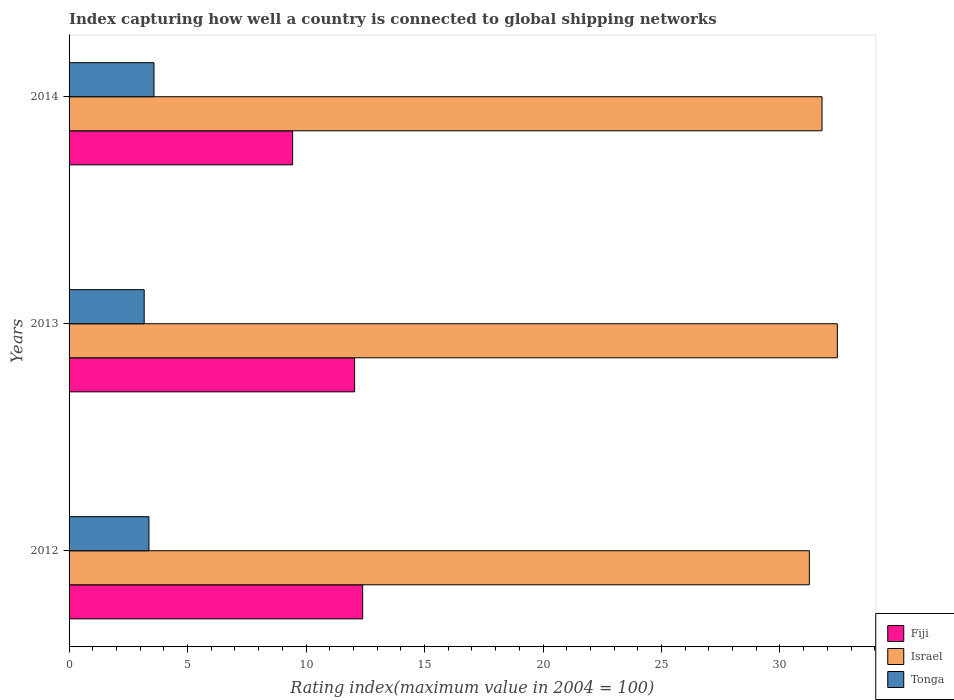How many different coloured bars are there?
Keep it short and to the point. 3. How many groups of bars are there?
Give a very brief answer. 3. Are the number of bars per tick equal to the number of legend labels?
Your answer should be very brief. Yes. Are the number of bars on each tick of the Y-axis equal?
Ensure brevity in your answer.  Yes. What is the rating index in Israel in 2014?
Offer a very short reply. 31.77. Across all years, what is the maximum rating index in Fiji?
Your response must be concise. 12.39. Across all years, what is the minimum rating index in Fiji?
Your response must be concise. 9.43. In which year was the rating index in Tonga maximum?
Your answer should be compact. 2014. What is the total rating index in Israel in the graph?
Your answer should be very brief. 95.43. What is the difference between the rating index in Israel in 2013 and that in 2014?
Keep it short and to the point. 0.65. What is the difference between the rating index in Israel in 2013 and the rating index in Tonga in 2012?
Make the answer very short. 29.05. What is the average rating index in Fiji per year?
Provide a short and direct response. 11.29. In the year 2014, what is the difference between the rating index in Israel and rating index in Tonga?
Offer a very short reply. 28.19. What is the ratio of the rating index in Israel in 2013 to that in 2014?
Provide a short and direct response. 1.02. Is the rating index in Israel in 2012 less than that in 2014?
Your response must be concise. Yes. Is the difference between the rating index in Israel in 2013 and 2014 greater than the difference between the rating index in Tonga in 2013 and 2014?
Your response must be concise. Yes. What is the difference between the highest and the second highest rating index in Tonga?
Keep it short and to the point. 0.21. What is the difference between the highest and the lowest rating index in Israel?
Your response must be concise. 1.18. In how many years, is the rating index in Tonga greater than the average rating index in Tonga taken over all years?
Give a very brief answer. 1. Is the sum of the rating index in Tonga in 2013 and 2014 greater than the maximum rating index in Israel across all years?
Provide a succinct answer. No. What does the 1st bar from the top in 2013 represents?
Keep it short and to the point. Tonga. What does the 1st bar from the bottom in 2014 represents?
Provide a succinct answer. Fiji. How many bars are there?
Provide a succinct answer. 9. Does the graph contain grids?
Give a very brief answer. No. How many legend labels are there?
Your answer should be compact. 3. How are the legend labels stacked?
Keep it short and to the point. Vertical. What is the title of the graph?
Your answer should be compact. Index capturing how well a country is connected to global shipping networks. What is the label or title of the X-axis?
Offer a very short reply. Rating index(maximum value in 2004 = 100). What is the Rating index(maximum value in 2004 = 100) of Fiji in 2012?
Your response must be concise. 12.39. What is the Rating index(maximum value in 2004 = 100) of Israel in 2012?
Provide a short and direct response. 31.24. What is the Rating index(maximum value in 2004 = 100) of Tonga in 2012?
Make the answer very short. 3.37. What is the Rating index(maximum value in 2004 = 100) in Fiji in 2013?
Keep it short and to the point. 12.05. What is the Rating index(maximum value in 2004 = 100) of Israel in 2013?
Your response must be concise. 32.42. What is the Rating index(maximum value in 2004 = 100) of Tonga in 2013?
Ensure brevity in your answer.  3.17. What is the Rating index(maximum value in 2004 = 100) of Fiji in 2014?
Offer a very short reply. 9.43. What is the Rating index(maximum value in 2004 = 100) of Israel in 2014?
Give a very brief answer. 31.77. What is the Rating index(maximum value in 2004 = 100) of Tonga in 2014?
Your response must be concise. 3.58. Across all years, what is the maximum Rating index(maximum value in 2004 = 100) of Fiji?
Provide a short and direct response. 12.39. Across all years, what is the maximum Rating index(maximum value in 2004 = 100) in Israel?
Ensure brevity in your answer.  32.42. Across all years, what is the maximum Rating index(maximum value in 2004 = 100) of Tonga?
Provide a short and direct response. 3.58. Across all years, what is the minimum Rating index(maximum value in 2004 = 100) in Fiji?
Your answer should be compact. 9.43. Across all years, what is the minimum Rating index(maximum value in 2004 = 100) of Israel?
Your answer should be compact. 31.24. Across all years, what is the minimum Rating index(maximum value in 2004 = 100) in Tonga?
Offer a very short reply. 3.17. What is the total Rating index(maximum value in 2004 = 100) in Fiji in the graph?
Ensure brevity in your answer.  33.87. What is the total Rating index(maximum value in 2004 = 100) of Israel in the graph?
Keep it short and to the point. 95.43. What is the total Rating index(maximum value in 2004 = 100) in Tonga in the graph?
Make the answer very short. 10.12. What is the difference between the Rating index(maximum value in 2004 = 100) of Fiji in 2012 and that in 2013?
Your response must be concise. 0.34. What is the difference between the Rating index(maximum value in 2004 = 100) of Israel in 2012 and that in 2013?
Provide a succinct answer. -1.18. What is the difference between the Rating index(maximum value in 2004 = 100) in Fiji in 2012 and that in 2014?
Make the answer very short. 2.96. What is the difference between the Rating index(maximum value in 2004 = 100) in Israel in 2012 and that in 2014?
Ensure brevity in your answer.  -0.53. What is the difference between the Rating index(maximum value in 2004 = 100) of Tonga in 2012 and that in 2014?
Ensure brevity in your answer.  -0.21. What is the difference between the Rating index(maximum value in 2004 = 100) of Fiji in 2013 and that in 2014?
Ensure brevity in your answer.  2.62. What is the difference between the Rating index(maximum value in 2004 = 100) of Israel in 2013 and that in 2014?
Offer a very short reply. 0.65. What is the difference between the Rating index(maximum value in 2004 = 100) of Tonga in 2013 and that in 2014?
Your answer should be very brief. -0.41. What is the difference between the Rating index(maximum value in 2004 = 100) in Fiji in 2012 and the Rating index(maximum value in 2004 = 100) in Israel in 2013?
Offer a terse response. -20.03. What is the difference between the Rating index(maximum value in 2004 = 100) of Fiji in 2012 and the Rating index(maximum value in 2004 = 100) of Tonga in 2013?
Ensure brevity in your answer.  9.22. What is the difference between the Rating index(maximum value in 2004 = 100) of Israel in 2012 and the Rating index(maximum value in 2004 = 100) of Tonga in 2013?
Your answer should be compact. 28.07. What is the difference between the Rating index(maximum value in 2004 = 100) of Fiji in 2012 and the Rating index(maximum value in 2004 = 100) of Israel in 2014?
Provide a succinct answer. -19.38. What is the difference between the Rating index(maximum value in 2004 = 100) in Fiji in 2012 and the Rating index(maximum value in 2004 = 100) in Tonga in 2014?
Offer a very short reply. 8.81. What is the difference between the Rating index(maximum value in 2004 = 100) of Israel in 2012 and the Rating index(maximum value in 2004 = 100) of Tonga in 2014?
Make the answer very short. 27.66. What is the difference between the Rating index(maximum value in 2004 = 100) of Fiji in 2013 and the Rating index(maximum value in 2004 = 100) of Israel in 2014?
Offer a terse response. -19.72. What is the difference between the Rating index(maximum value in 2004 = 100) in Fiji in 2013 and the Rating index(maximum value in 2004 = 100) in Tonga in 2014?
Your response must be concise. 8.47. What is the difference between the Rating index(maximum value in 2004 = 100) in Israel in 2013 and the Rating index(maximum value in 2004 = 100) in Tonga in 2014?
Offer a very short reply. 28.84. What is the average Rating index(maximum value in 2004 = 100) in Fiji per year?
Offer a very short reply. 11.29. What is the average Rating index(maximum value in 2004 = 100) of Israel per year?
Make the answer very short. 31.81. What is the average Rating index(maximum value in 2004 = 100) in Tonga per year?
Give a very brief answer. 3.37. In the year 2012, what is the difference between the Rating index(maximum value in 2004 = 100) in Fiji and Rating index(maximum value in 2004 = 100) in Israel?
Your answer should be compact. -18.85. In the year 2012, what is the difference between the Rating index(maximum value in 2004 = 100) in Fiji and Rating index(maximum value in 2004 = 100) in Tonga?
Your answer should be compact. 9.02. In the year 2012, what is the difference between the Rating index(maximum value in 2004 = 100) in Israel and Rating index(maximum value in 2004 = 100) in Tonga?
Your answer should be compact. 27.87. In the year 2013, what is the difference between the Rating index(maximum value in 2004 = 100) of Fiji and Rating index(maximum value in 2004 = 100) of Israel?
Your response must be concise. -20.37. In the year 2013, what is the difference between the Rating index(maximum value in 2004 = 100) in Fiji and Rating index(maximum value in 2004 = 100) in Tonga?
Offer a terse response. 8.88. In the year 2013, what is the difference between the Rating index(maximum value in 2004 = 100) of Israel and Rating index(maximum value in 2004 = 100) of Tonga?
Offer a terse response. 29.25. In the year 2014, what is the difference between the Rating index(maximum value in 2004 = 100) of Fiji and Rating index(maximum value in 2004 = 100) of Israel?
Your answer should be compact. -22.34. In the year 2014, what is the difference between the Rating index(maximum value in 2004 = 100) of Fiji and Rating index(maximum value in 2004 = 100) of Tonga?
Give a very brief answer. 5.85. In the year 2014, what is the difference between the Rating index(maximum value in 2004 = 100) in Israel and Rating index(maximum value in 2004 = 100) in Tonga?
Your answer should be very brief. 28.19. What is the ratio of the Rating index(maximum value in 2004 = 100) in Fiji in 2012 to that in 2013?
Ensure brevity in your answer.  1.03. What is the ratio of the Rating index(maximum value in 2004 = 100) in Israel in 2012 to that in 2013?
Keep it short and to the point. 0.96. What is the ratio of the Rating index(maximum value in 2004 = 100) of Tonga in 2012 to that in 2013?
Your answer should be compact. 1.06. What is the ratio of the Rating index(maximum value in 2004 = 100) in Fiji in 2012 to that in 2014?
Keep it short and to the point. 1.31. What is the ratio of the Rating index(maximum value in 2004 = 100) of Israel in 2012 to that in 2014?
Offer a terse response. 0.98. What is the ratio of the Rating index(maximum value in 2004 = 100) in Tonga in 2012 to that in 2014?
Give a very brief answer. 0.94. What is the ratio of the Rating index(maximum value in 2004 = 100) in Fiji in 2013 to that in 2014?
Offer a very short reply. 1.28. What is the ratio of the Rating index(maximum value in 2004 = 100) of Israel in 2013 to that in 2014?
Keep it short and to the point. 1.02. What is the ratio of the Rating index(maximum value in 2004 = 100) in Tonga in 2013 to that in 2014?
Your answer should be compact. 0.88. What is the difference between the highest and the second highest Rating index(maximum value in 2004 = 100) in Fiji?
Provide a short and direct response. 0.34. What is the difference between the highest and the second highest Rating index(maximum value in 2004 = 100) in Israel?
Your answer should be very brief. 0.65. What is the difference between the highest and the second highest Rating index(maximum value in 2004 = 100) in Tonga?
Offer a very short reply. 0.21. What is the difference between the highest and the lowest Rating index(maximum value in 2004 = 100) in Fiji?
Keep it short and to the point. 2.96. What is the difference between the highest and the lowest Rating index(maximum value in 2004 = 100) in Israel?
Provide a succinct answer. 1.18. What is the difference between the highest and the lowest Rating index(maximum value in 2004 = 100) of Tonga?
Your answer should be very brief. 0.41. 